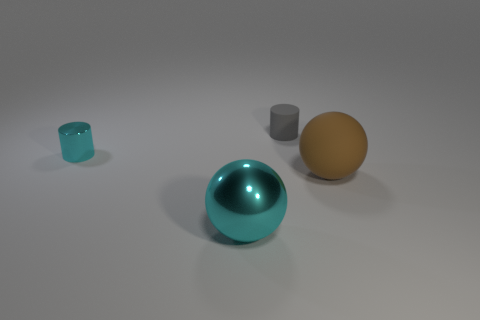Add 4 large green matte objects. How many objects exist? 8 Subtract all gray cylinders. How many cylinders are left? 1 Subtract 1 balls. How many balls are left? 1 Subtract all blue cylinders. Subtract all red spheres. How many cylinders are left? 2 Add 1 tiny objects. How many tiny objects exist? 3 Subtract 0 purple cylinders. How many objects are left? 4 Subtract all large red rubber cylinders. Subtract all big brown rubber things. How many objects are left? 3 Add 1 large metallic objects. How many large metallic objects are left? 2 